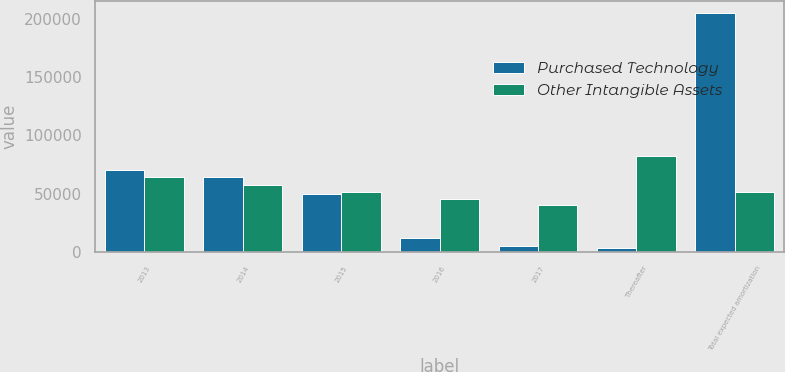Convert chart. <chart><loc_0><loc_0><loc_500><loc_500><stacked_bar_chart><ecel><fcel>2013<fcel>2014<fcel>2015<fcel>2016<fcel>2017<fcel>Thereafter<fcel>Total expected amortization<nl><fcel>Purchased Technology<fcel>70613<fcel>64451<fcel>49779<fcel>11505<fcel>5372<fcel>3316<fcel>205036<nl><fcel>Other Intangible Assets<fcel>64429<fcel>56995<fcel>50977<fcel>45359<fcel>40026<fcel>82214<fcel>50977<nl></chart> 